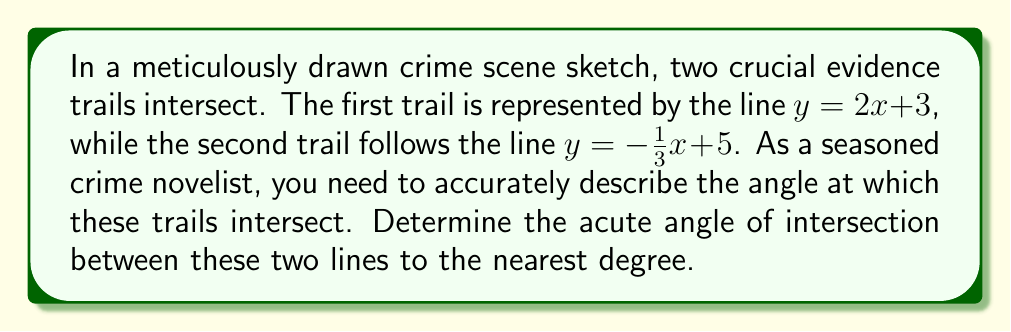Give your solution to this math problem. To find the angle of intersection between two lines, we can use the following steps:

1. Calculate the slopes of both lines:
   For line 1: $m_1 = 2$
   For line 2: $m_2 = -\frac{1}{3}$

2. Use the formula for the tangent of the angle between two lines:
   $$\tan \theta = \left|\frac{m_1 - m_2}{1 + m_1m_2}\right|$$

3. Substitute the slopes into the formula:
   $$\tan \theta = \left|\frac{2 - (-\frac{1}{3})}{1 + 2(-\frac{1}{3})}\right| = \left|\frac{2 + \frac{1}{3}}{1 - \frac{2}{3}}\right| = \left|\frac{\frac{7}{3}}{\frac{1}{3}}\right| = 7$$

4. Calculate the angle using the inverse tangent function:
   $$\theta = \arctan(7) \approx 81.87^\circ$$

5. Round to the nearest degree:
   $\theta \approx 82^\circ$

Note that this is the acute angle between the lines. The obtuse angle would be $180^\circ - 82^\circ = 98^\circ$.
Answer: $82^\circ$ 